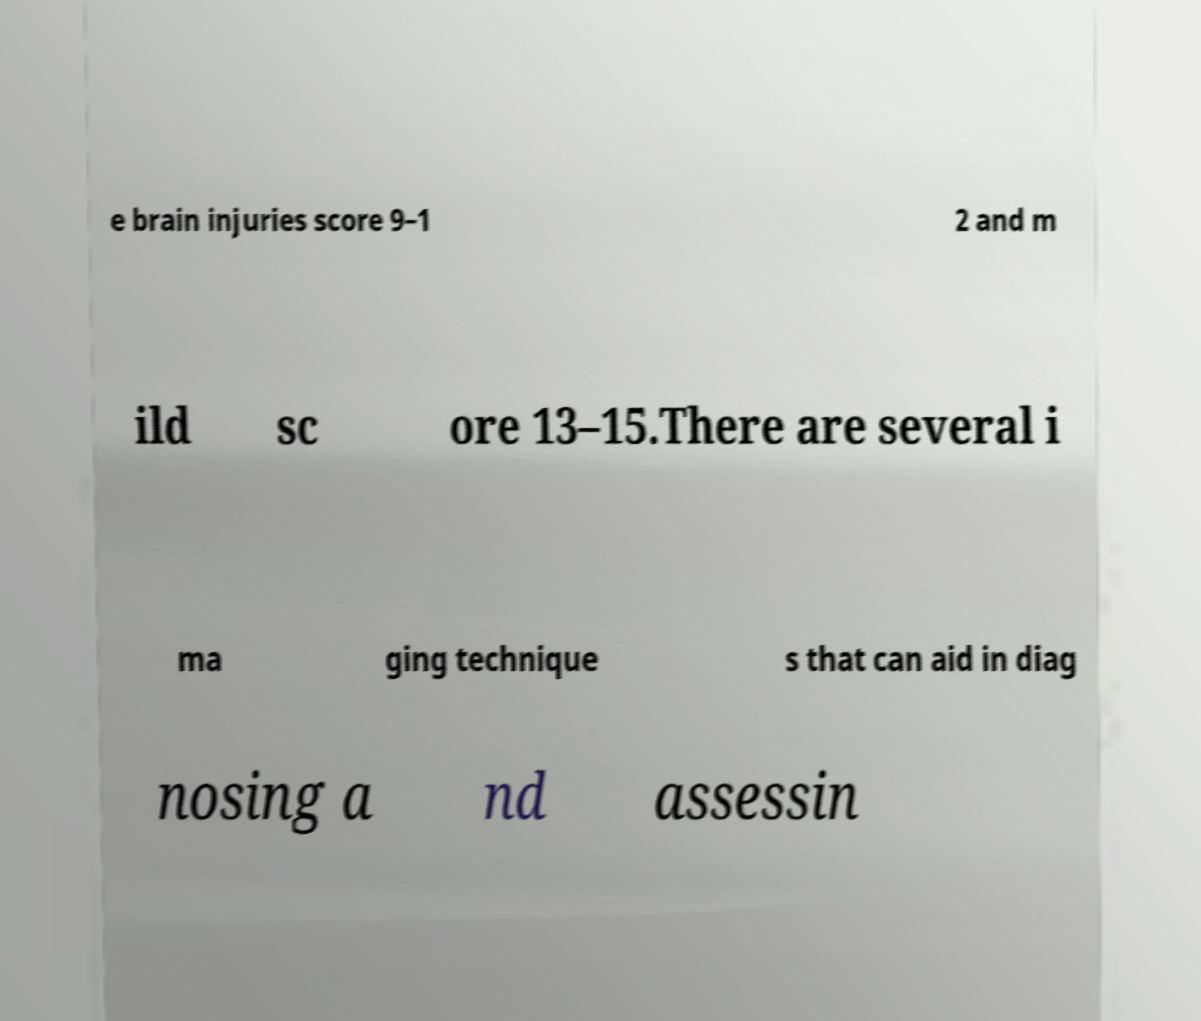Can you accurately transcribe the text from the provided image for me? e brain injuries score 9–1 2 and m ild sc ore 13–15.There are several i ma ging technique s that can aid in diag nosing a nd assessin 